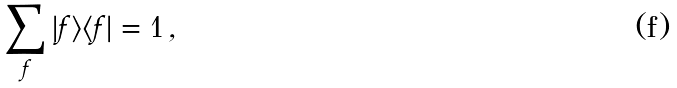Convert formula to latex. <formula><loc_0><loc_0><loc_500><loc_500>\sum _ { f } | f \rangle \langle f | = 1 \, ,</formula> 